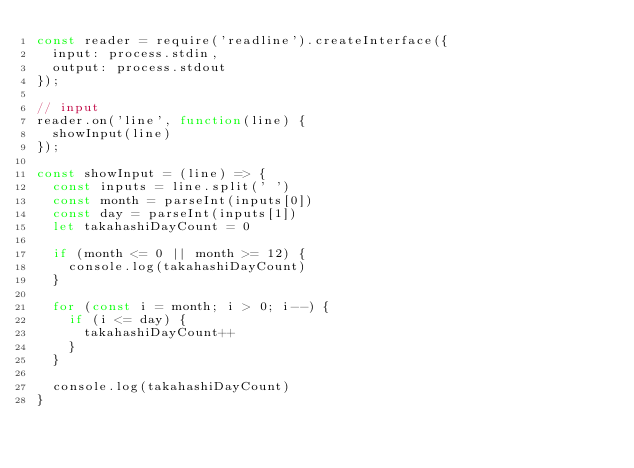Convert code to text. <code><loc_0><loc_0><loc_500><loc_500><_JavaScript_>const reader = require('readline').createInterface({
  input: process.stdin,
  output: process.stdout
});

// input
reader.on('line', function(line) {
  showInput(line)
});

const showInput = (line) => {
  const inputs = line.split(' ')
  const month = parseInt(inputs[0])
  const day = parseInt(inputs[1])
  let takahashiDayCount = 0

  if (month <= 0 || month >= 12) {
    console.log(takahashiDayCount)
  }

  for (const i = month; i > 0; i--) {
    if (i <= day) {
      takahashiDayCount++
    }
  }

  console.log(takahashiDayCount)
}</code> 